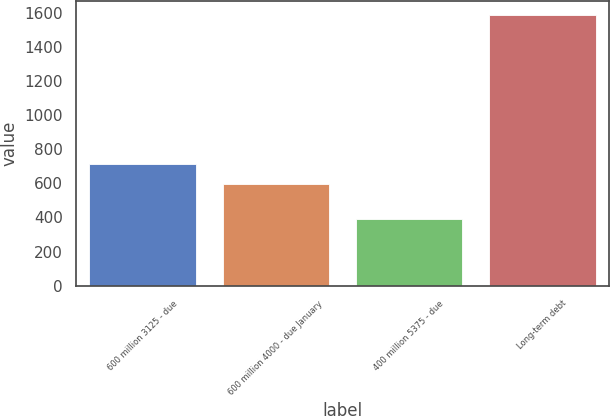Convert chart. <chart><loc_0><loc_0><loc_500><loc_500><bar_chart><fcel>600 million 3125 - due<fcel>600 million 4000 - due January<fcel>400 million 5375 - due<fcel>Long-term debt<nl><fcel>715.78<fcel>596.2<fcel>393.5<fcel>1589.3<nl></chart> 